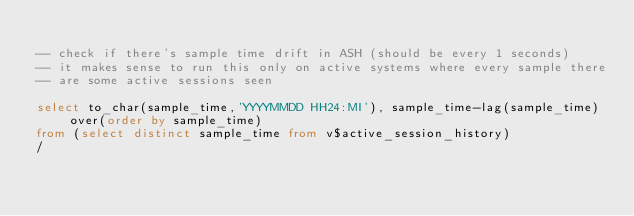Convert code to text. <code><loc_0><loc_0><loc_500><loc_500><_SQL_>
-- check if there's sample time drift in ASH (should be every 1 seconds)
-- it makes sense to run this only on active systems where every sample there
-- are some active sessions seen

select to_char(sample_time,'YYYYMMDD HH24:MI'), sample_time-lag(sample_time) over(order by sample_time) 
from (select distinct sample_time from v$active_session_history)
/


</code> 